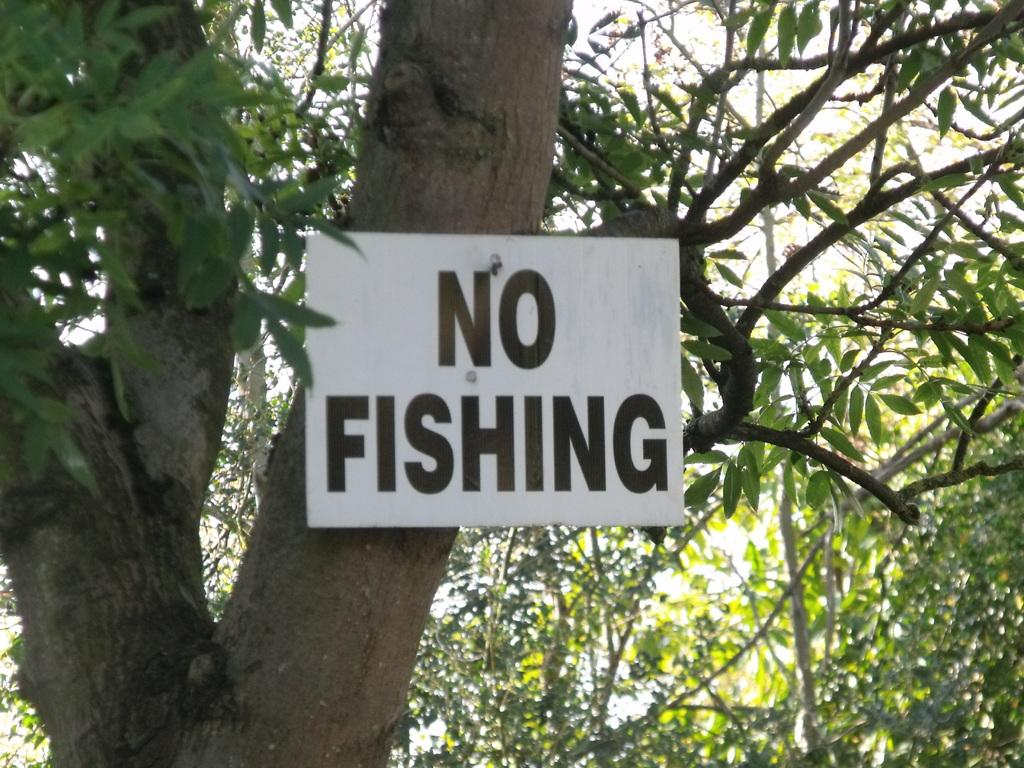What type of plant can be seen in the image? There is a tree in the image. What other object is present in the image? There is a board in the image. What type of education can be seen in the image? There is no reference to education in the image; it features a tree and a board. What type of gold object is visible in the image? There is no gold object present in the image. 